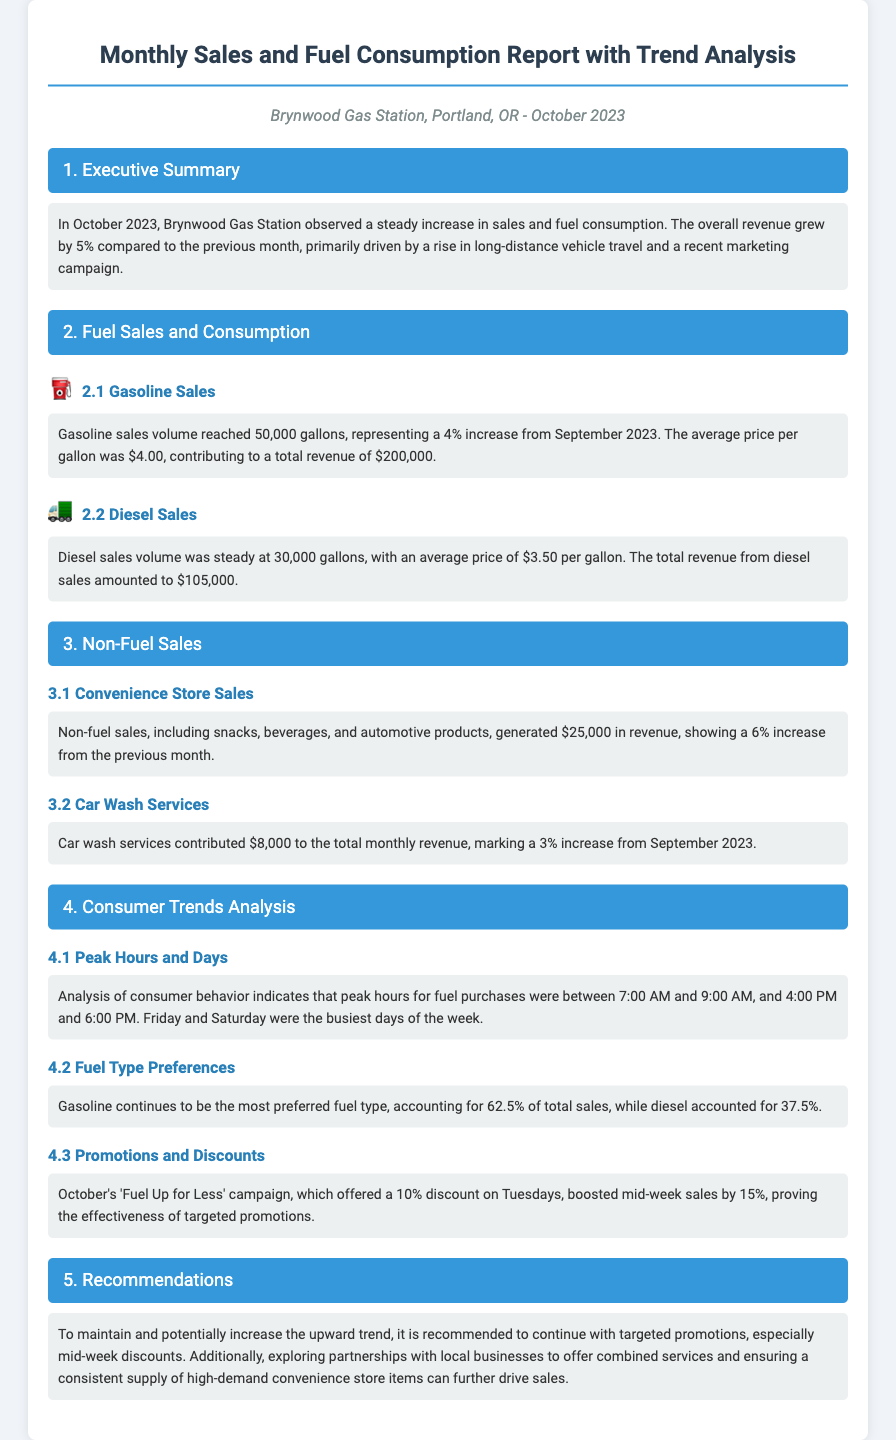what was the percentage increase in overall revenue? The document states that the overall revenue grew by 5% compared to the previous month.
Answer: 5% how many gallons of gasoline were sold? The gasoline sales volume reached 50,000 gallons as mentioned in the report.
Answer: 50,000 gallons what was the average price of diesel per gallon? The average price for diesel per gallon is $3.50 as indicated in the diesel sales section.
Answer: $3.50 which marketing campaign was mentioned? The report highlights the 'Fuel Up for Less' campaign as a key marketing strategy during October.
Answer: Fuel Up for Less what percentage of total fuel sales did gasoline account for? Gasoline accounted for 62.5% of total sales as stated in the fuel type preferences section.
Answer: 62.5% what was the revenue generated from convenience store sales? The revenue from convenience store sales is reported as $25,000.
Answer: $25,000 which days of the week saw the highest sales? According to consumer behavior analysis, Friday and Saturday were identified as the busiest days.
Answer: Friday and Saturday what was the increase percentage of car wash services revenue? The document states that car wash services marked a 3% increase from the previous month.
Answer: 3% what recommendation is made regarding promotions? The report recommends continuing with targeted promotions, particularly mid-week discounts.
Answer: Targeted promotions 